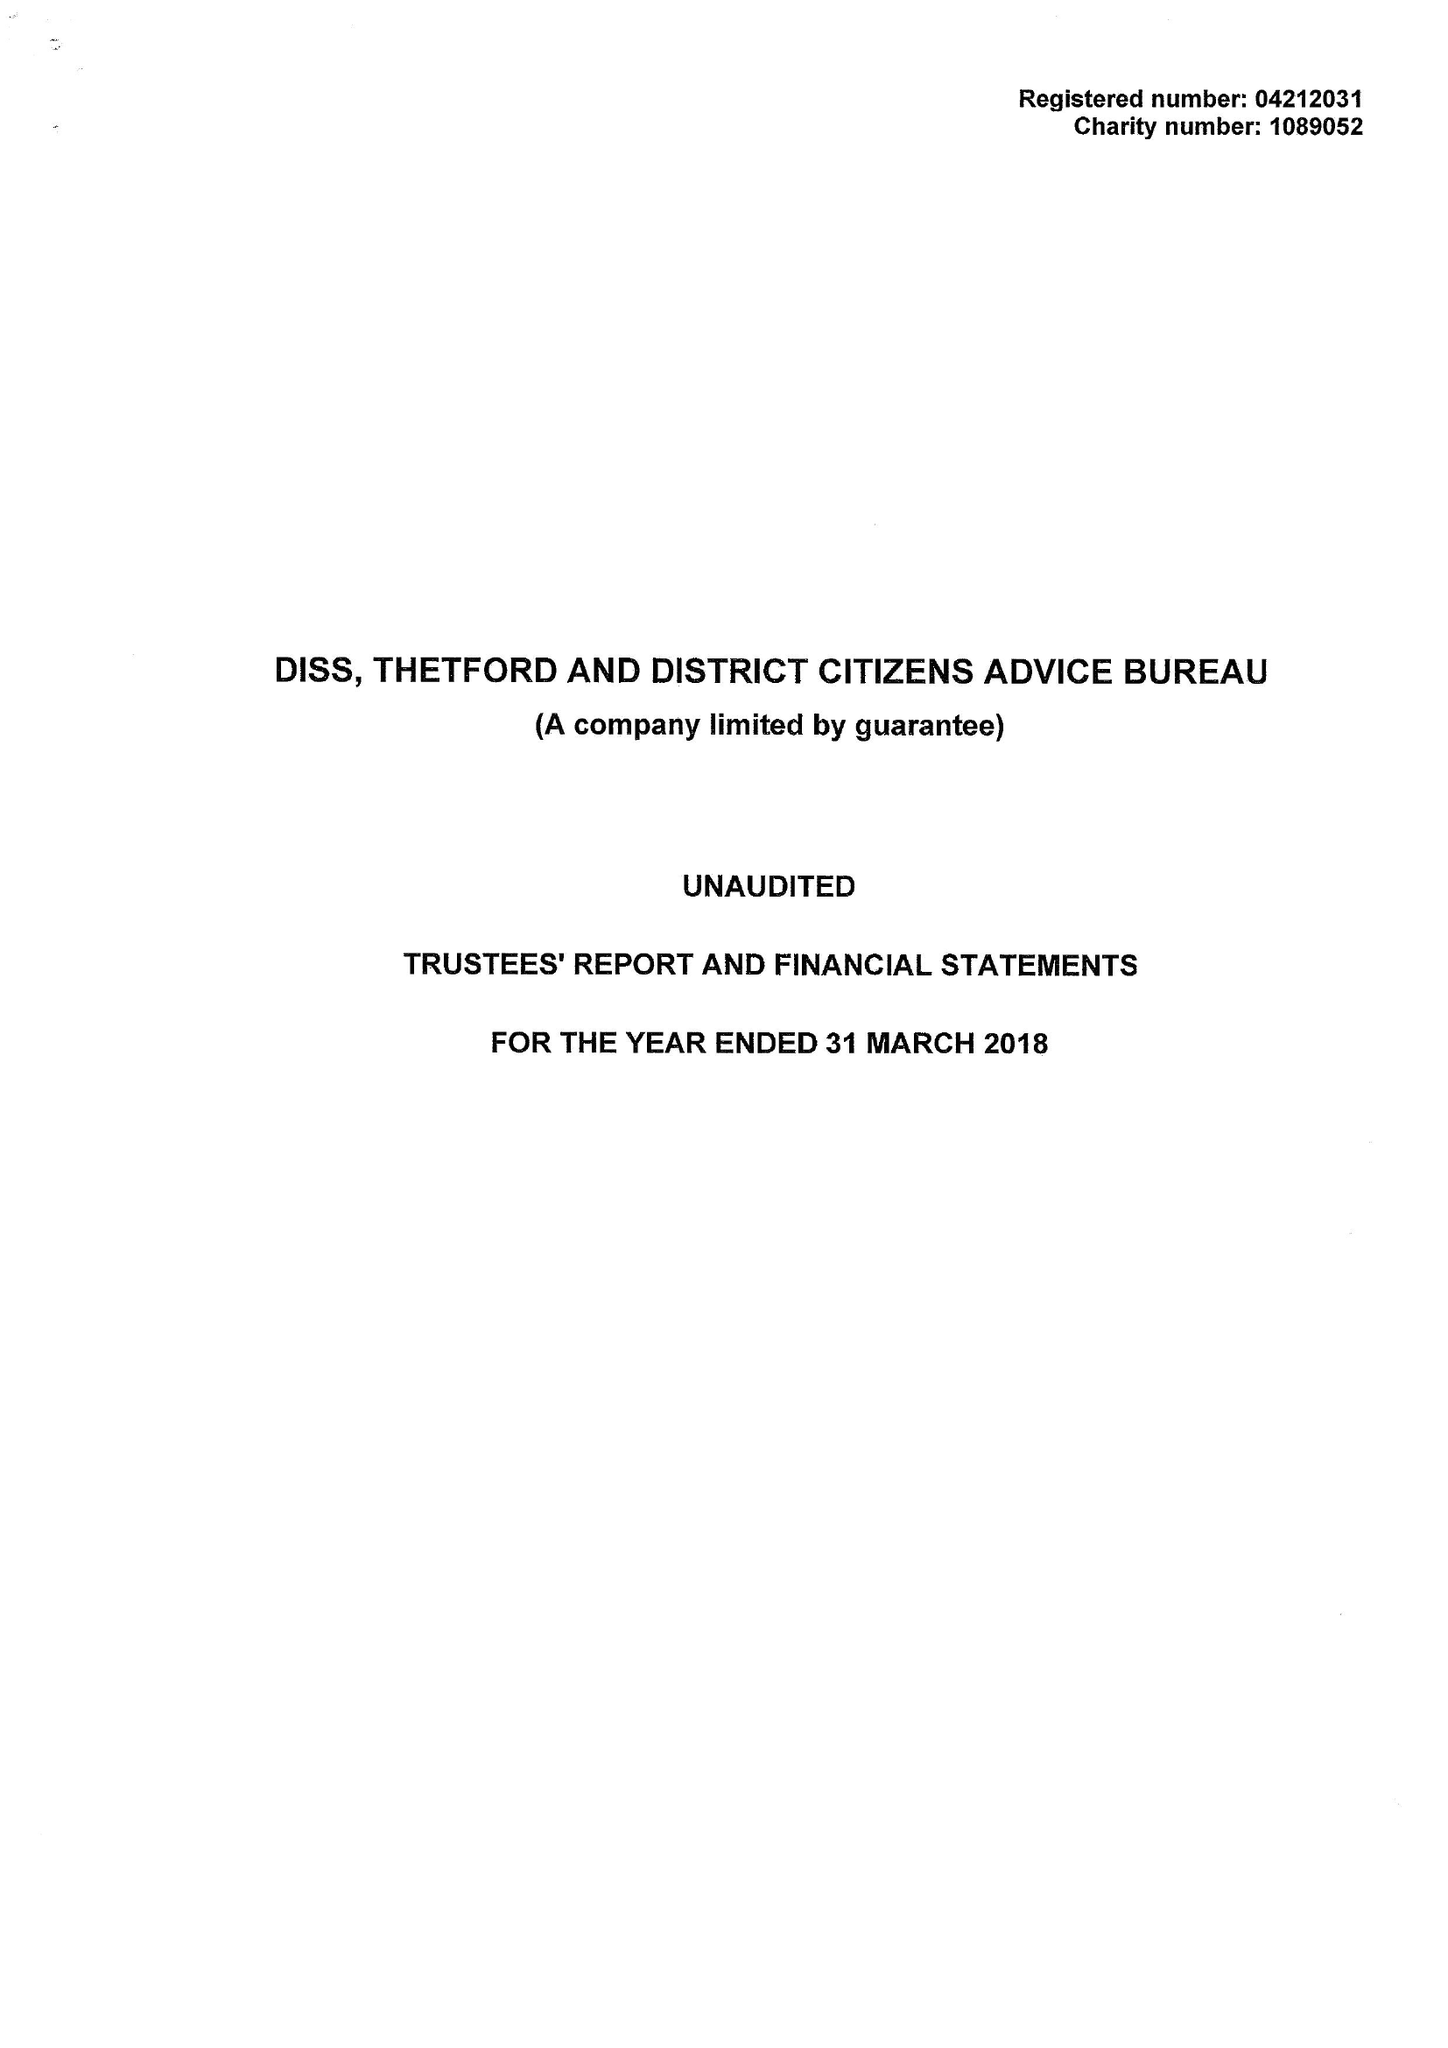What is the value for the address__street_line?
Answer the question using a single word or phrase. SHELFANGER ROAD 